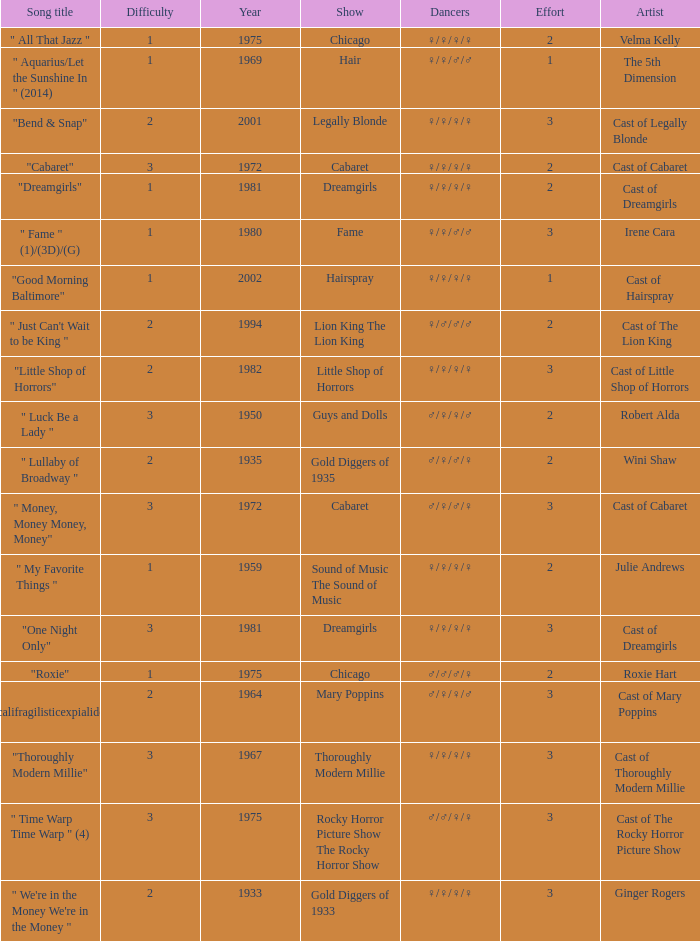What show featured the song "little shop of horrors"? Little Shop of Horrors. 